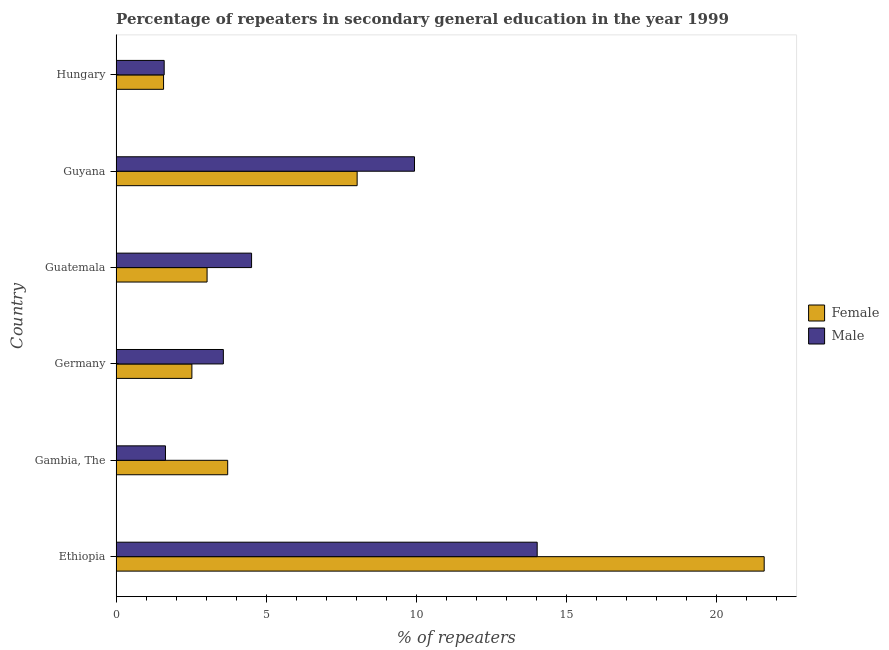How many different coloured bars are there?
Your answer should be very brief. 2. Are the number of bars per tick equal to the number of legend labels?
Your response must be concise. Yes. Are the number of bars on each tick of the Y-axis equal?
Your answer should be very brief. Yes. How many bars are there on the 3rd tick from the top?
Keep it short and to the point. 2. What is the label of the 4th group of bars from the top?
Your answer should be very brief. Germany. In how many cases, is the number of bars for a given country not equal to the number of legend labels?
Make the answer very short. 0. What is the percentage of female repeaters in Germany?
Offer a very short reply. 2.53. Across all countries, what is the maximum percentage of male repeaters?
Your answer should be compact. 14.04. Across all countries, what is the minimum percentage of male repeaters?
Your answer should be very brief. 1.6. In which country was the percentage of male repeaters maximum?
Your response must be concise. Ethiopia. In which country was the percentage of male repeaters minimum?
Provide a short and direct response. Hungary. What is the total percentage of male repeaters in the graph?
Offer a terse response. 35.32. What is the difference between the percentage of male repeaters in Ethiopia and that in Germany?
Offer a very short reply. 10.46. What is the difference between the percentage of female repeaters in Guatemala and the percentage of male repeaters in Guyana?
Your answer should be compact. -6.91. What is the average percentage of male repeaters per country?
Keep it short and to the point. 5.89. What is the difference between the percentage of female repeaters and percentage of male repeaters in Germany?
Give a very brief answer. -1.05. What is the ratio of the percentage of male repeaters in Guatemala to that in Guyana?
Keep it short and to the point. 0.45. Is the percentage of male repeaters in Guyana less than that in Hungary?
Offer a very short reply. No. Is the difference between the percentage of female repeaters in Germany and Hungary greater than the difference between the percentage of male repeaters in Germany and Hungary?
Provide a short and direct response. No. What is the difference between the highest and the second highest percentage of male repeaters?
Give a very brief answer. 4.09. What is the difference between the highest and the lowest percentage of male repeaters?
Provide a succinct answer. 12.43. Is the sum of the percentage of male repeaters in Ethiopia and Gambia, The greater than the maximum percentage of female repeaters across all countries?
Your response must be concise. No. What does the 2nd bar from the bottom in Germany represents?
Offer a terse response. Male. How many countries are there in the graph?
Ensure brevity in your answer.  6. What is the difference between two consecutive major ticks on the X-axis?
Provide a succinct answer. 5. Does the graph contain any zero values?
Provide a short and direct response. No. How are the legend labels stacked?
Your answer should be compact. Vertical. What is the title of the graph?
Your answer should be very brief. Percentage of repeaters in secondary general education in the year 1999. Does "External balance on goods" appear as one of the legend labels in the graph?
Your answer should be compact. No. What is the label or title of the X-axis?
Give a very brief answer. % of repeaters. What is the % of repeaters in Female in Ethiopia?
Your answer should be very brief. 21.6. What is the % of repeaters of Male in Ethiopia?
Offer a very short reply. 14.04. What is the % of repeaters of Female in Gambia, The?
Make the answer very short. 3.72. What is the % of repeaters of Male in Gambia, The?
Your answer should be very brief. 1.64. What is the % of repeaters of Female in Germany?
Keep it short and to the point. 2.53. What is the % of repeaters in Male in Germany?
Provide a short and direct response. 3.57. What is the % of repeaters in Female in Guatemala?
Provide a succinct answer. 3.03. What is the % of repeaters of Male in Guatemala?
Give a very brief answer. 4.51. What is the % of repeaters of Female in Guyana?
Make the answer very short. 8.03. What is the % of repeaters of Male in Guyana?
Your answer should be very brief. 9.95. What is the % of repeaters in Female in Hungary?
Provide a short and direct response. 1.58. What is the % of repeaters of Male in Hungary?
Ensure brevity in your answer.  1.6. Across all countries, what is the maximum % of repeaters in Female?
Your response must be concise. 21.6. Across all countries, what is the maximum % of repeaters of Male?
Your answer should be very brief. 14.04. Across all countries, what is the minimum % of repeaters of Female?
Your response must be concise. 1.58. Across all countries, what is the minimum % of repeaters of Male?
Your response must be concise. 1.6. What is the total % of repeaters of Female in the graph?
Ensure brevity in your answer.  40.49. What is the total % of repeaters of Male in the graph?
Make the answer very short. 35.32. What is the difference between the % of repeaters of Female in Ethiopia and that in Gambia, The?
Provide a succinct answer. 17.88. What is the difference between the % of repeaters in Male in Ethiopia and that in Gambia, The?
Provide a short and direct response. 12.39. What is the difference between the % of repeaters of Female in Ethiopia and that in Germany?
Offer a terse response. 19.08. What is the difference between the % of repeaters in Male in Ethiopia and that in Germany?
Make the answer very short. 10.46. What is the difference between the % of repeaters of Female in Ethiopia and that in Guatemala?
Make the answer very short. 18.57. What is the difference between the % of repeaters of Male in Ethiopia and that in Guatemala?
Provide a short and direct response. 9.52. What is the difference between the % of repeaters in Female in Ethiopia and that in Guyana?
Provide a succinct answer. 13.57. What is the difference between the % of repeaters of Male in Ethiopia and that in Guyana?
Provide a succinct answer. 4.09. What is the difference between the % of repeaters of Female in Ethiopia and that in Hungary?
Provide a short and direct response. 20.02. What is the difference between the % of repeaters of Male in Ethiopia and that in Hungary?
Offer a terse response. 12.43. What is the difference between the % of repeaters of Female in Gambia, The and that in Germany?
Your answer should be compact. 1.19. What is the difference between the % of repeaters of Male in Gambia, The and that in Germany?
Offer a very short reply. -1.93. What is the difference between the % of repeaters of Female in Gambia, The and that in Guatemala?
Offer a terse response. 0.69. What is the difference between the % of repeaters in Male in Gambia, The and that in Guatemala?
Make the answer very short. -2.87. What is the difference between the % of repeaters in Female in Gambia, The and that in Guyana?
Keep it short and to the point. -4.32. What is the difference between the % of repeaters of Male in Gambia, The and that in Guyana?
Your response must be concise. -8.3. What is the difference between the % of repeaters in Female in Gambia, The and that in Hungary?
Make the answer very short. 2.14. What is the difference between the % of repeaters of Male in Gambia, The and that in Hungary?
Give a very brief answer. 0.04. What is the difference between the % of repeaters of Female in Germany and that in Guatemala?
Give a very brief answer. -0.51. What is the difference between the % of repeaters in Male in Germany and that in Guatemala?
Give a very brief answer. -0.94. What is the difference between the % of repeaters in Female in Germany and that in Guyana?
Your answer should be compact. -5.51. What is the difference between the % of repeaters in Male in Germany and that in Guyana?
Provide a succinct answer. -6.37. What is the difference between the % of repeaters in Female in Germany and that in Hungary?
Your answer should be very brief. 0.94. What is the difference between the % of repeaters in Male in Germany and that in Hungary?
Your response must be concise. 1.97. What is the difference between the % of repeaters in Female in Guatemala and that in Guyana?
Your answer should be compact. -5. What is the difference between the % of repeaters in Male in Guatemala and that in Guyana?
Keep it short and to the point. -5.43. What is the difference between the % of repeaters of Female in Guatemala and that in Hungary?
Offer a very short reply. 1.45. What is the difference between the % of repeaters of Male in Guatemala and that in Hungary?
Your answer should be compact. 2.91. What is the difference between the % of repeaters of Female in Guyana and that in Hungary?
Offer a very short reply. 6.45. What is the difference between the % of repeaters in Male in Guyana and that in Hungary?
Provide a short and direct response. 8.34. What is the difference between the % of repeaters of Female in Ethiopia and the % of repeaters of Male in Gambia, The?
Offer a terse response. 19.96. What is the difference between the % of repeaters of Female in Ethiopia and the % of repeaters of Male in Germany?
Provide a short and direct response. 18.03. What is the difference between the % of repeaters in Female in Ethiopia and the % of repeaters in Male in Guatemala?
Offer a very short reply. 17.09. What is the difference between the % of repeaters in Female in Ethiopia and the % of repeaters in Male in Guyana?
Your answer should be very brief. 11.66. What is the difference between the % of repeaters of Female in Ethiopia and the % of repeaters of Male in Hungary?
Offer a very short reply. 20. What is the difference between the % of repeaters of Female in Gambia, The and the % of repeaters of Male in Germany?
Your response must be concise. 0.14. What is the difference between the % of repeaters in Female in Gambia, The and the % of repeaters in Male in Guatemala?
Your answer should be very brief. -0.8. What is the difference between the % of repeaters of Female in Gambia, The and the % of repeaters of Male in Guyana?
Your answer should be very brief. -6.23. What is the difference between the % of repeaters of Female in Gambia, The and the % of repeaters of Male in Hungary?
Offer a very short reply. 2.12. What is the difference between the % of repeaters of Female in Germany and the % of repeaters of Male in Guatemala?
Your answer should be very brief. -1.99. What is the difference between the % of repeaters in Female in Germany and the % of repeaters in Male in Guyana?
Give a very brief answer. -7.42. What is the difference between the % of repeaters of Female in Germany and the % of repeaters of Male in Hungary?
Ensure brevity in your answer.  0.92. What is the difference between the % of repeaters in Female in Guatemala and the % of repeaters in Male in Guyana?
Offer a terse response. -6.91. What is the difference between the % of repeaters of Female in Guatemala and the % of repeaters of Male in Hungary?
Your answer should be compact. 1.43. What is the difference between the % of repeaters of Female in Guyana and the % of repeaters of Male in Hungary?
Offer a terse response. 6.43. What is the average % of repeaters of Female per country?
Your answer should be very brief. 6.75. What is the average % of repeaters of Male per country?
Ensure brevity in your answer.  5.89. What is the difference between the % of repeaters in Female and % of repeaters in Male in Ethiopia?
Ensure brevity in your answer.  7.57. What is the difference between the % of repeaters of Female and % of repeaters of Male in Gambia, The?
Provide a short and direct response. 2.07. What is the difference between the % of repeaters of Female and % of repeaters of Male in Germany?
Your answer should be compact. -1.05. What is the difference between the % of repeaters in Female and % of repeaters in Male in Guatemala?
Your answer should be compact. -1.48. What is the difference between the % of repeaters in Female and % of repeaters in Male in Guyana?
Your response must be concise. -1.91. What is the difference between the % of repeaters of Female and % of repeaters of Male in Hungary?
Your answer should be very brief. -0.02. What is the ratio of the % of repeaters of Female in Ethiopia to that in Gambia, The?
Make the answer very short. 5.81. What is the ratio of the % of repeaters of Male in Ethiopia to that in Gambia, The?
Offer a very short reply. 8.53. What is the ratio of the % of repeaters in Female in Ethiopia to that in Germany?
Your answer should be compact. 8.55. What is the ratio of the % of repeaters in Male in Ethiopia to that in Germany?
Your answer should be compact. 3.93. What is the ratio of the % of repeaters of Female in Ethiopia to that in Guatemala?
Offer a terse response. 7.12. What is the ratio of the % of repeaters of Male in Ethiopia to that in Guatemala?
Your response must be concise. 3.11. What is the ratio of the % of repeaters in Female in Ethiopia to that in Guyana?
Give a very brief answer. 2.69. What is the ratio of the % of repeaters of Male in Ethiopia to that in Guyana?
Give a very brief answer. 1.41. What is the ratio of the % of repeaters of Female in Ethiopia to that in Hungary?
Provide a short and direct response. 13.66. What is the ratio of the % of repeaters in Male in Ethiopia to that in Hungary?
Your answer should be very brief. 8.76. What is the ratio of the % of repeaters of Female in Gambia, The to that in Germany?
Give a very brief answer. 1.47. What is the ratio of the % of repeaters of Male in Gambia, The to that in Germany?
Offer a very short reply. 0.46. What is the ratio of the % of repeaters in Female in Gambia, The to that in Guatemala?
Make the answer very short. 1.23. What is the ratio of the % of repeaters of Male in Gambia, The to that in Guatemala?
Your answer should be very brief. 0.36. What is the ratio of the % of repeaters in Female in Gambia, The to that in Guyana?
Ensure brevity in your answer.  0.46. What is the ratio of the % of repeaters of Male in Gambia, The to that in Guyana?
Give a very brief answer. 0.17. What is the ratio of the % of repeaters in Female in Gambia, The to that in Hungary?
Your answer should be compact. 2.35. What is the ratio of the % of repeaters in Male in Gambia, The to that in Hungary?
Your response must be concise. 1.03. What is the ratio of the % of repeaters in Female in Germany to that in Guatemala?
Keep it short and to the point. 0.83. What is the ratio of the % of repeaters in Male in Germany to that in Guatemala?
Offer a terse response. 0.79. What is the ratio of the % of repeaters in Female in Germany to that in Guyana?
Make the answer very short. 0.31. What is the ratio of the % of repeaters in Male in Germany to that in Guyana?
Your response must be concise. 0.36. What is the ratio of the % of repeaters in Female in Germany to that in Hungary?
Provide a short and direct response. 1.6. What is the ratio of the % of repeaters of Male in Germany to that in Hungary?
Keep it short and to the point. 2.23. What is the ratio of the % of repeaters of Female in Guatemala to that in Guyana?
Provide a short and direct response. 0.38. What is the ratio of the % of repeaters in Male in Guatemala to that in Guyana?
Your answer should be compact. 0.45. What is the ratio of the % of repeaters of Female in Guatemala to that in Hungary?
Your answer should be compact. 1.92. What is the ratio of the % of repeaters of Male in Guatemala to that in Hungary?
Provide a succinct answer. 2.82. What is the ratio of the % of repeaters in Female in Guyana to that in Hungary?
Make the answer very short. 5.08. What is the ratio of the % of repeaters in Male in Guyana to that in Hungary?
Your answer should be compact. 6.21. What is the difference between the highest and the second highest % of repeaters of Female?
Your answer should be very brief. 13.57. What is the difference between the highest and the second highest % of repeaters of Male?
Provide a succinct answer. 4.09. What is the difference between the highest and the lowest % of repeaters of Female?
Ensure brevity in your answer.  20.02. What is the difference between the highest and the lowest % of repeaters of Male?
Keep it short and to the point. 12.43. 